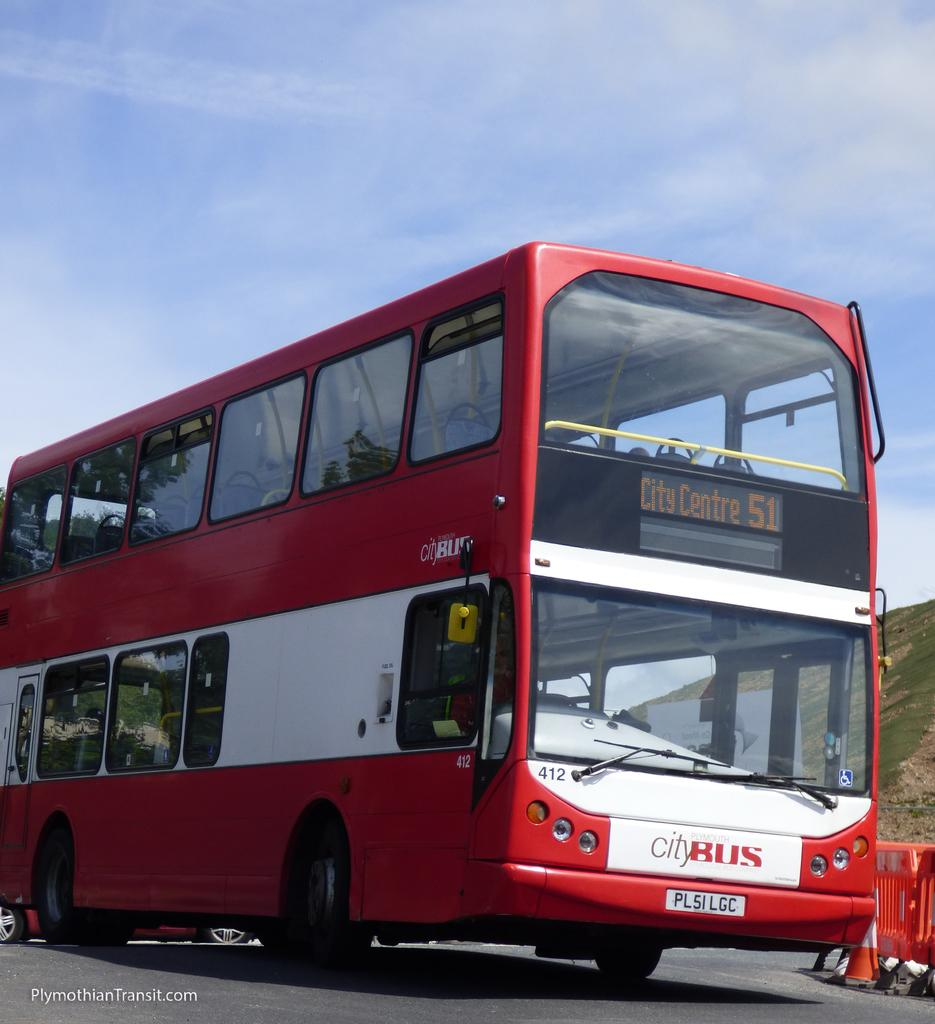What type of vehicle is in the image? There is a red double-decker bus in the image. Where is the bus located? The bus is on the road. What is written on the bus? The bus has "City Bus" written on it. What object can be seen on the road? There is a traffic cone on the road. What can be seen in the distance in the image? There is a hill visible in the background of the image. Is the dog's tongue visible in the image? There is no dog or tongue present in the image. How does the bus navigate through the quicksand in the image? There is no quicksand in the image; the bus is on the road. 